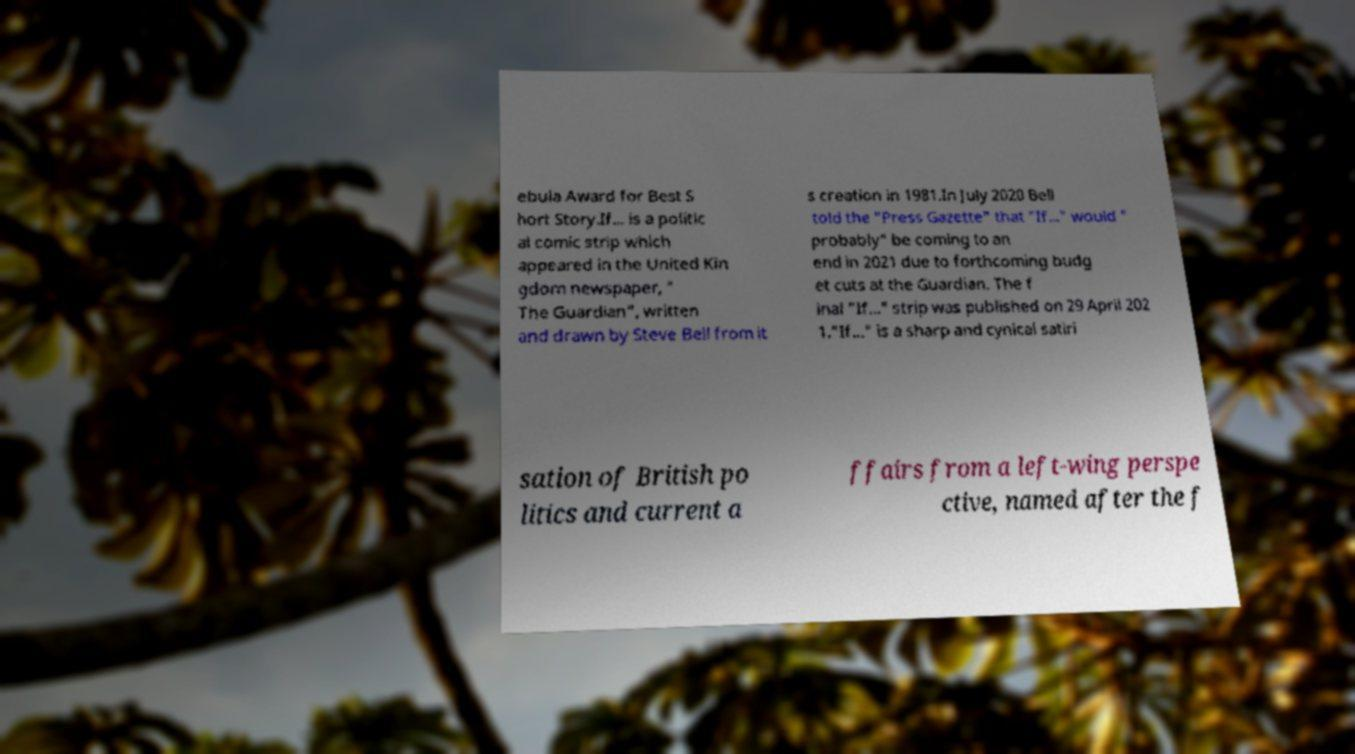For documentation purposes, I need the text within this image transcribed. Could you provide that? ebula Award for Best S hort Story.If... is a politic al comic strip which appeared in the United Kin gdom newspaper, " The Guardian", written and drawn by Steve Bell from it s creation in 1981.In July 2020 Bell told the "Press Gazette" that "If..." would " probably" be coming to an end in 2021 due to forthcoming budg et cuts at the Guardian. The f inal "If..." strip was published on 29 April 202 1."If..." is a sharp and cynical satiri sation of British po litics and current a ffairs from a left-wing perspe ctive, named after the f 